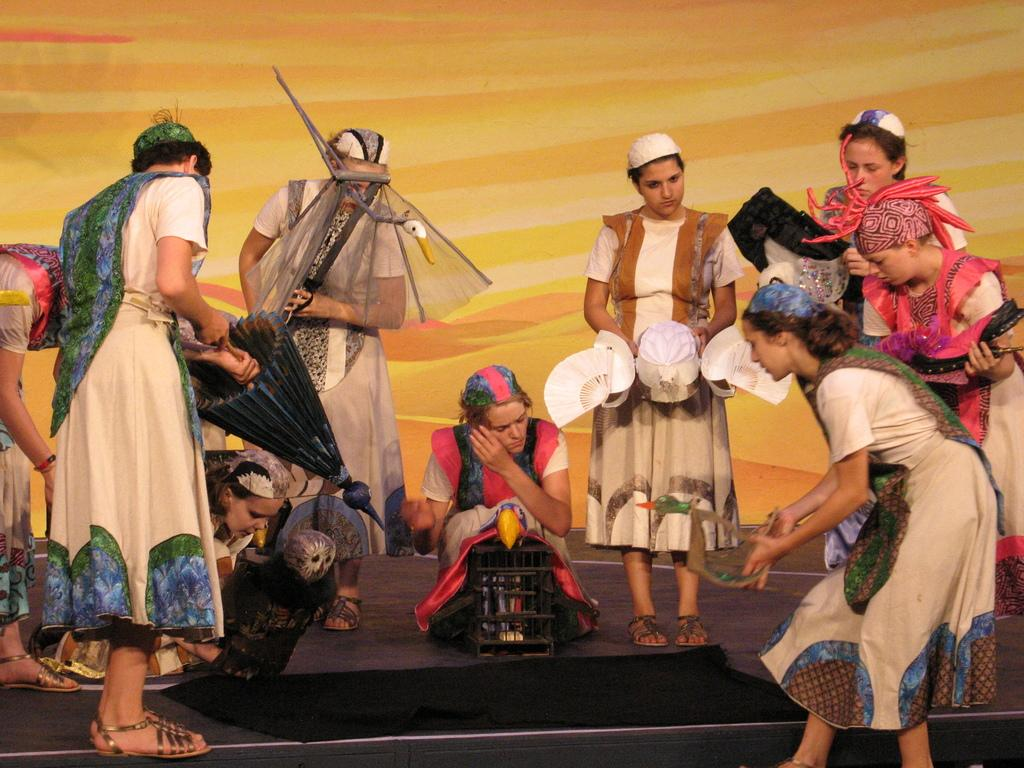Who or what can be seen in the image? There are people in the image. What are the people doing in the image? The people are holding objects. What can be seen in the distance behind the people? There is a wall in the background of the image. What type of sponge can be seen on the wall in the image? There is no sponge present on the wall in the image. What type of silk fabric is draped over the people in the image? There is no silk fabric present in the image; the people are holding objects. 